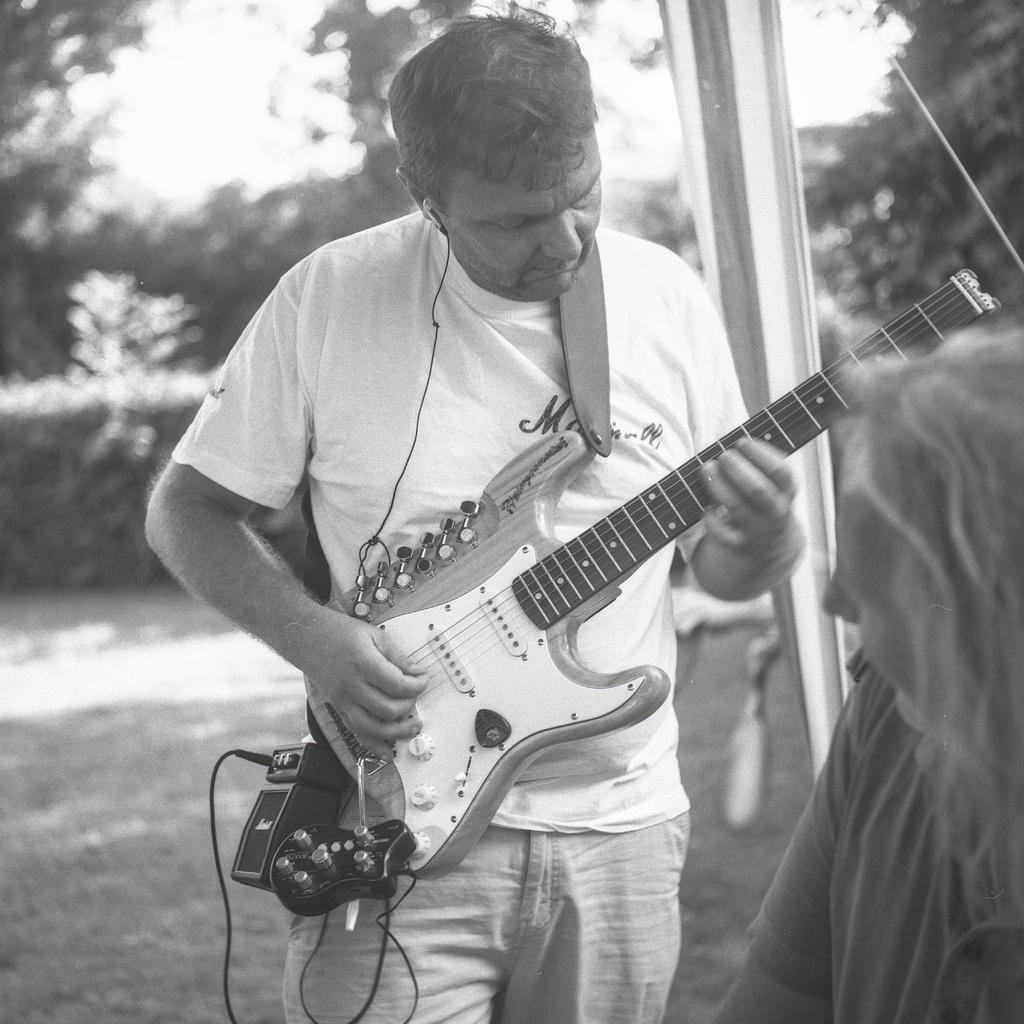Describe this image in one or two sentences. A man is playing a guitar while a woman is watching. 